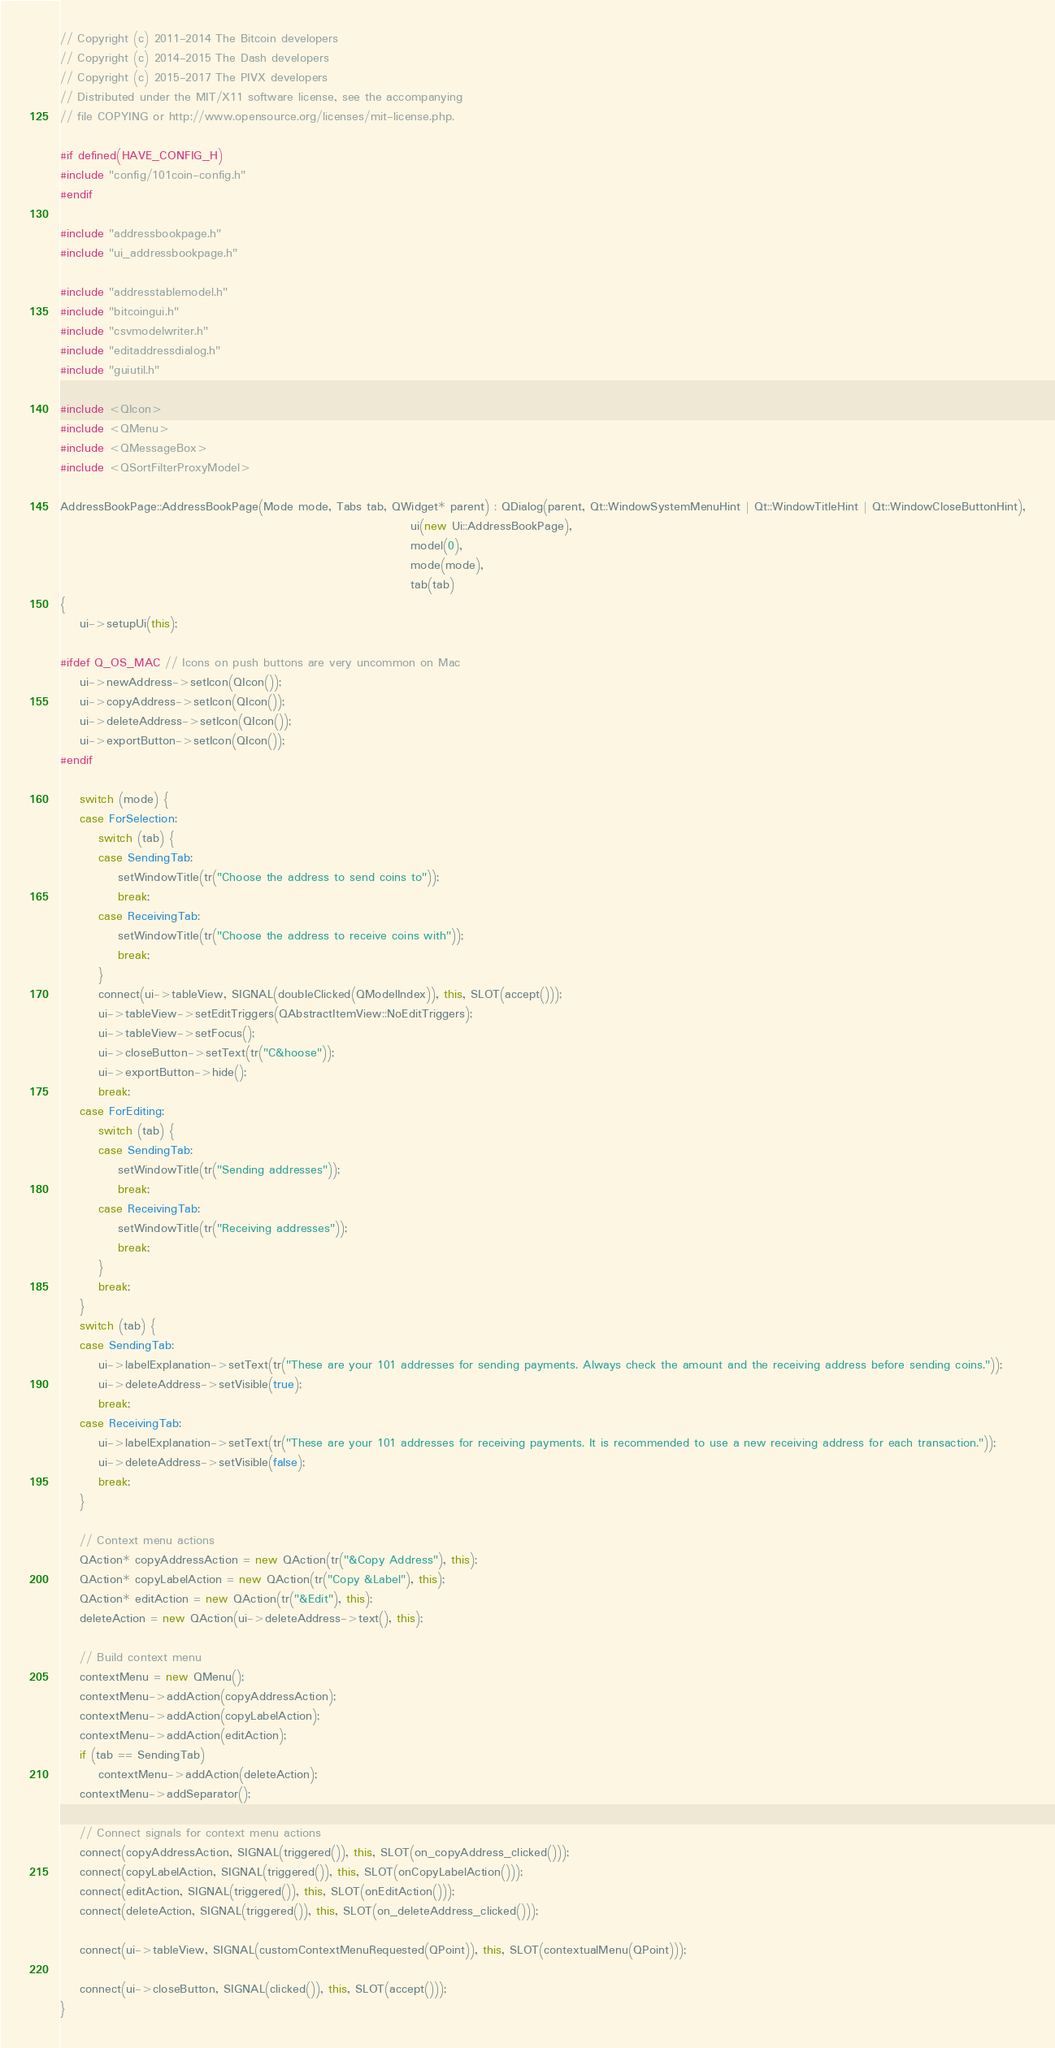<code> <loc_0><loc_0><loc_500><loc_500><_C++_>// Copyright (c) 2011-2014 The Bitcoin developers
// Copyright (c) 2014-2015 The Dash developers
// Copyright (c) 2015-2017 The PIVX developers
// Distributed under the MIT/X11 software license, see the accompanying
// file COPYING or http://www.opensource.org/licenses/mit-license.php.

#if defined(HAVE_CONFIG_H)
#include "config/101coin-config.h"
#endif

#include "addressbookpage.h"
#include "ui_addressbookpage.h"

#include "addresstablemodel.h"
#include "bitcoingui.h"
#include "csvmodelwriter.h"
#include "editaddressdialog.h"
#include "guiutil.h"

#include <QIcon>
#include <QMenu>
#include <QMessageBox>
#include <QSortFilterProxyModel>

AddressBookPage::AddressBookPage(Mode mode, Tabs tab, QWidget* parent) : QDialog(parent, Qt::WindowSystemMenuHint | Qt::WindowTitleHint | Qt::WindowCloseButtonHint),
                                                                         ui(new Ui::AddressBookPage),
                                                                         model(0),
                                                                         mode(mode),
                                                                         tab(tab)
{
    ui->setupUi(this);

#ifdef Q_OS_MAC // Icons on push buttons are very uncommon on Mac
    ui->newAddress->setIcon(QIcon());
    ui->copyAddress->setIcon(QIcon());
    ui->deleteAddress->setIcon(QIcon());
    ui->exportButton->setIcon(QIcon());
#endif

    switch (mode) {
    case ForSelection:
        switch (tab) {
        case SendingTab:
            setWindowTitle(tr("Choose the address to send coins to"));
            break;
        case ReceivingTab:
            setWindowTitle(tr("Choose the address to receive coins with"));
            break;
        }
        connect(ui->tableView, SIGNAL(doubleClicked(QModelIndex)), this, SLOT(accept()));
        ui->tableView->setEditTriggers(QAbstractItemView::NoEditTriggers);
        ui->tableView->setFocus();
        ui->closeButton->setText(tr("C&hoose"));
        ui->exportButton->hide();
        break;
    case ForEditing:
        switch (tab) {
        case SendingTab:
            setWindowTitle(tr("Sending addresses"));
            break;
        case ReceivingTab:
            setWindowTitle(tr("Receiving addresses"));
            break;
        }
        break;
    }
    switch (tab) {
    case SendingTab:
        ui->labelExplanation->setText(tr("These are your 101 addresses for sending payments. Always check the amount and the receiving address before sending coins."));
        ui->deleteAddress->setVisible(true);
        break;
    case ReceivingTab:
        ui->labelExplanation->setText(tr("These are your 101 addresses for receiving payments. It is recommended to use a new receiving address for each transaction."));
        ui->deleteAddress->setVisible(false);
        break;
    }

    // Context menu actions
    QAction* copyAddressAction = new QAction(tr("&Copy Address"), this);
    QAction* copyLabelAction = new QAction(tr("Copy &Label"), this);
    QAction* editAction = new QAction(tr("&Edit"), this);
    deleteAction = new QAction(ui->deleteAddress->text(), this);

    // Build context menu
    contextMenu = new QMenu();
    contextMenu->addAction(copyAddressAction);
    contextMenu->addAction(copyLabelAction);
    contextMenu->addAction(editAction);
    if (tab == SendingTab)
        contextMenu->addAction(deleteAction);
    contextMenu->addSeparator();

    // Connect signals for context menu actions
    connect(copyAddressAction, SIGNAL(triggered()), this, SLOT(on_copyAddress_clicked()));
    connect(copyLabelAction, SIGNAL(triggered()), this, SLOT(onCopyLabelAction()));
    connect(editAction, SIGNAL(triggered()), this, SLOT(onEditAction()));
    connect(deleteAction, SIGNAL(triggered()), this, SLOT(on_deleteAddress_clicked()));

    connect(ui->tableView, SIGNAL(customContextMenuRequested(QPoint)), this, SLOT(contextualMenu(QPoint)));

    connect(ui->closeButton, SIGNAL(clicked()), this, SLOT(accept()));
}
</code> 